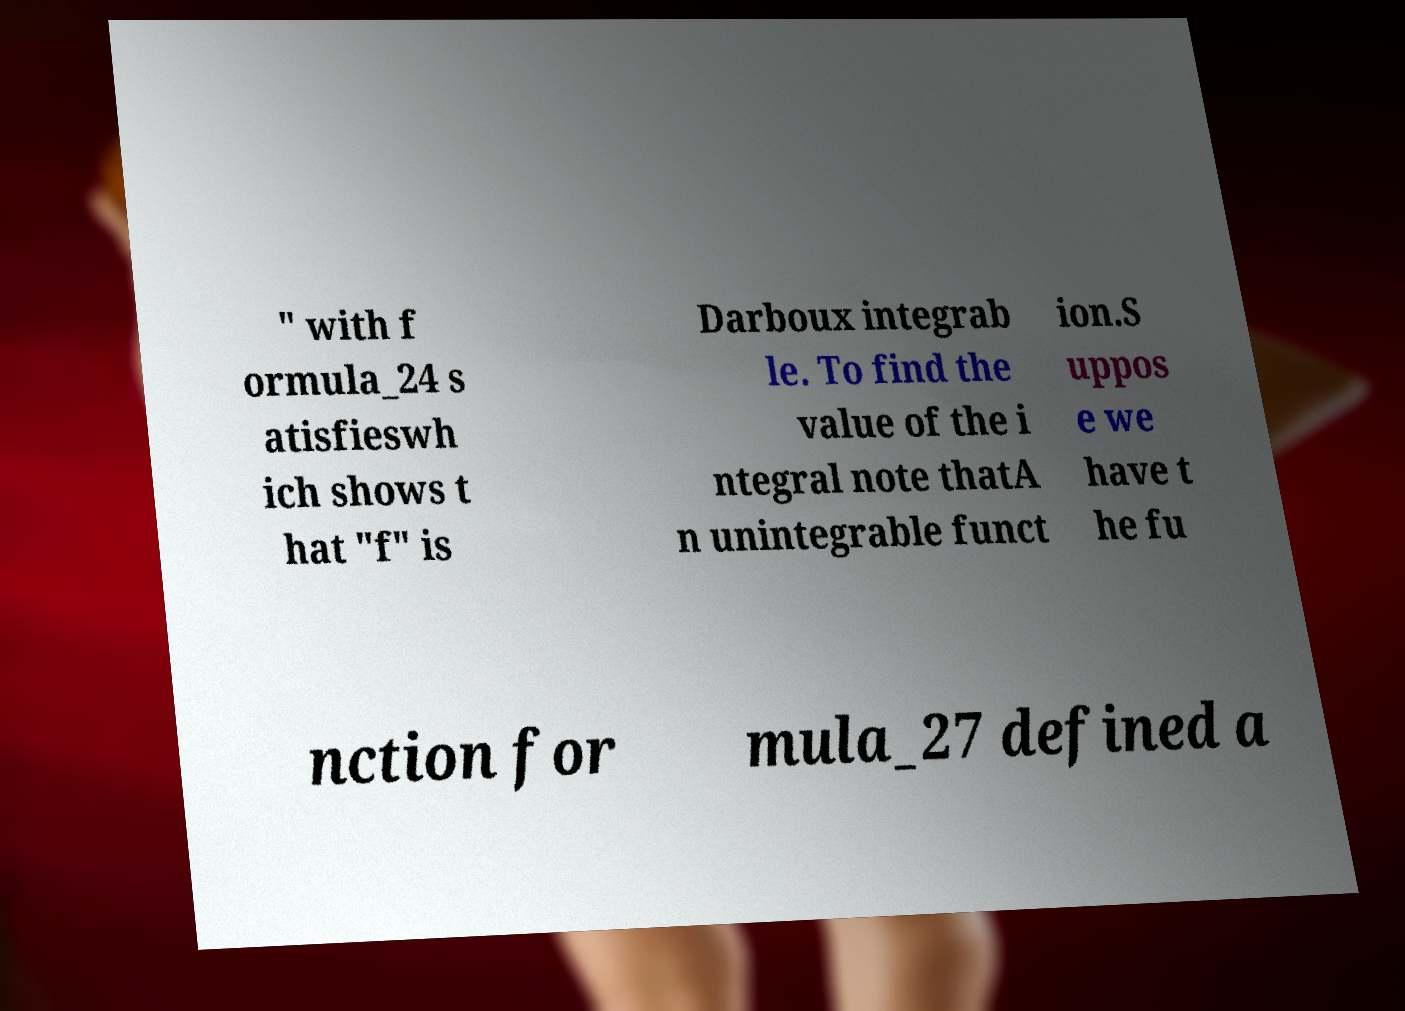I need the written content from this picture converted into text. Can you do that? " with f ormula_24 s atisfieswh ich shows t hat "f" is Darboux integrab le. To find the value of the i ntegral note thatA n unintegrable funct ion.S uppos e we have t he fu nction for mula_27 defined a 